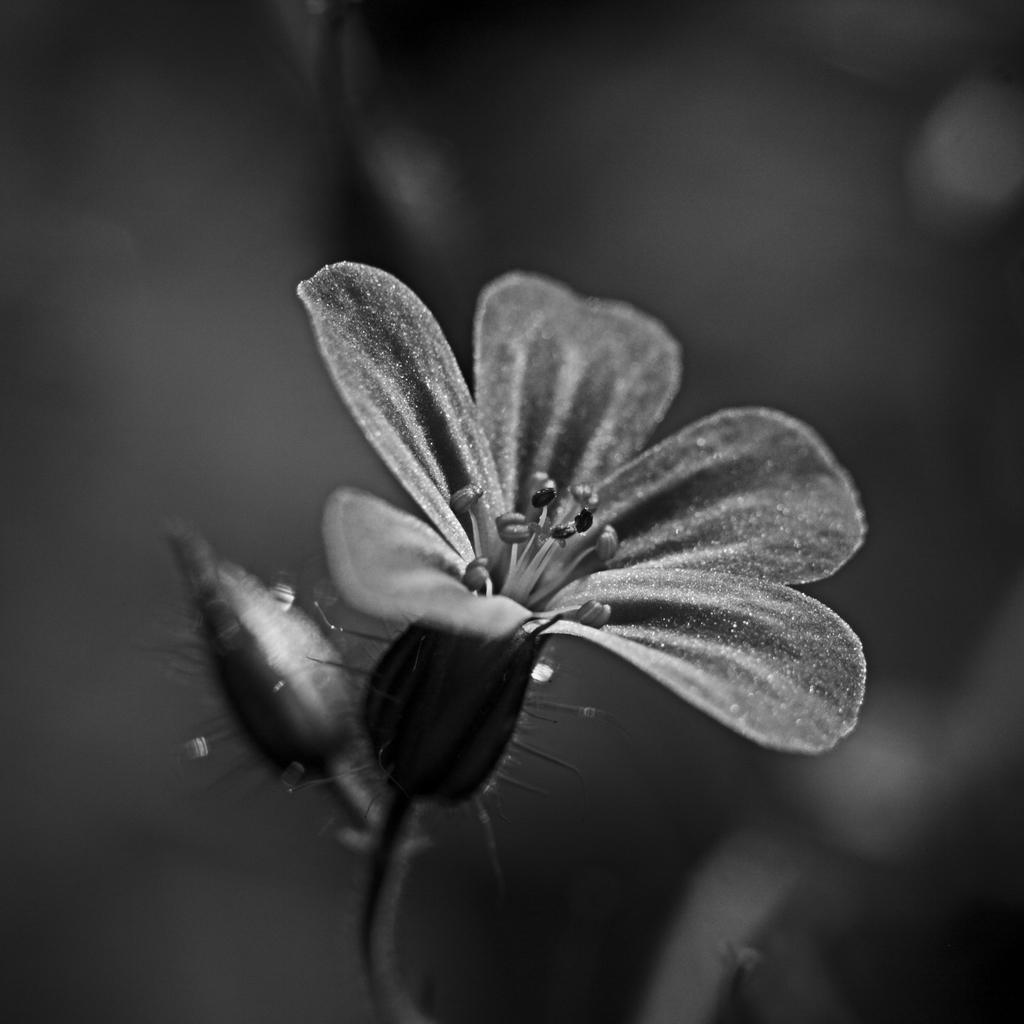Describe this image in one or two sentences. In this image I can see in the middle there is a flower, beside it there is a bud. 